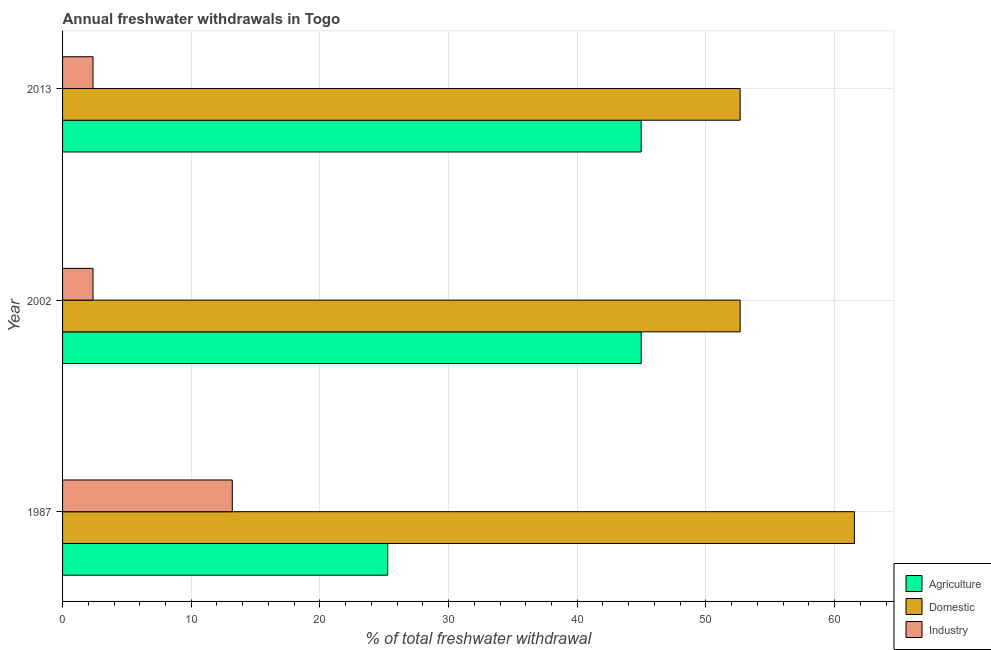How many different coloured bars are there?
Give a very brief answer. 3. How many groups of bars are there?
Your response must be concise. 3. Are the number of bars on each tick of the Y-axis equal?
Offer a very short reply. Yes. What is the label of the 2nd group of bars from the top?
Your answer should be compact. 2002. What is the percentage of freshwater withdrawal for domestic purposes in 2013?
Offer a very short reply. 52.66. Across all years, what is the maximum percentage of freshwater withdrawal for industry?
Give a very brief answer. 13.19. Across all years, what is the minimum percentage of freshwater withdrawal for agriculture?
Your response must be concise. 25.27. In which year was the percentage of freshwater withdrawal for domestic purposes maximum?
Offer a terse response. 1987. In which year was the percentage of freshwater withdrawal for industry minimum?
Make the answer very short. 2002. What is the total percentage of freshwater withdrawal for industry in the graph?
Offer a very short reply. 17.92. What is the difference between the percentage of freshwater withdrawal for agriculture in 1987 and that in 2013?
Offer a very short reply. -19.7. What is the difference between the percentage of freshwater withdrawal for domestic purposes in 1987 and the percentage of freshwater withdrawal for agriculture in 2013?
Your answer should be compact. 16.57. What is the average percentage of freshwater withdrawal for agriculture per year?
Offer a very short reply. 38.4. In the year 1987, what is the difference between the percentage of freshwater withdrawal for domestic purposes and percentage of freshwater withdrawal for industry?
Ensure brevity in your answer.  48.35. In how many years, is the percentage of freshwater withdrawal for agriculture greater than 62 %?
Offer a very short reply. 0. What is the ratio of the percentage of freshwater withdrawal for agriculture in 1987 to that in 2013?
Ensure brevity in your answer.  0.56. Is the difference between the percentage of freshwater withdrawal for domestic purposes in 1987 and 2013 greater than the difference between the percentage of freshwater withdrawal for agriculture in 1987 and 2013?
Provide a succinct answer. Yes. What is the difference between the highest and the second highest percentage of freshwater withdrawal for industry?
Provide a succinct answer. 10.82. What is the difference between the highest and the lowest percentage of freshwater withdrawal for domestic purposes?
Your response must be concise. 8.88. In how many years, is the percentage of freshwater withdrawal for industry greater than the average percentage of freshwater withdrawal for industry taken over all years?
Provide a short and direct response. 1. Is the sum of the percentage of freshwater withdrawal for industry in 2002 and 2013 greater than the maximum percentage of freshwater withdrawal for domestic purposes across all years?
Your answer should be very brief. No. What does the 2nd bar from the top in 2002 represents?
Your answer should be very brief. Domestic. What does the 1st bar from the bottom in 2002 represents?
Keep it short and to the point. Agriculture. Is it the case that in every year, the sum of the percentage of freshwater withdrawal for agriculture and percentage of freshwater withdrawal for domestic purposes is greater than the percentage of freshwater withdrawal for industry?
Offer a terse response. Yes. Are all the bars in the graph horizontal?
Give a very brief answer. Yes. How many years are there in the graph?
Offer a terse response. 3. What is the difference between two consecutive major ticks on the X-axis?
Offer a very short reply. 10. Where does the legend appear in the graph?
Offer a very short reply. Bottom right. How many legend labels are there?
Give a very brief answer. 3. What is the title of the graph?
Offer a very short reply. Annual freshwater withdrawals in Togo. What is the label or title of the X-axis?
Keep it short and to the point. % of total freshwater withdrawal. What is the % of total freshwater withdrawal in Agriculture in 1987?
Keep it short and to the point. 25.27. What is the % of total freshwater withdrawal in Domestic in 1987?
Give a very brief answer. 61.54. What is the % of total freshwater withdrawal in Industry in 1987?
Your response must be concise. 13.19. What is the % of total freshwater withdrawal of Agriculture in 2002?
Give a very brief answer. 44.97. What is the % of total freshwater withdrawal of Domestic in 2002?
Make the answer very short. 52.66. What is the % of total freshwater withdrawal of Industry in 2002?
Ensure brevity in your answer.  2.37. What is the % of total freshwater withdrawal of Agriculture in 2013?
Make the answer very short. 44.97. What is the % of total freshwater withdrawal in Domestic in 2013?
Make the answer very short. 52.66. What is the % of total freshwater withdrawal in Industry in 2013?
Make the answer very short. 2.37. Across all years, what is the maximum % of total freshwater withdrawal of Agriculture?
Provide a succinct answer. 44.97. Across all years, what is the maximum % of total freshwater withdrawal in Domestic?
Provide a succinct answer. 61.54. Across all years, what is the maximum % of total freshwater withdrawal of Industry?
Your response must be concise. 13.19. Across all years, what is the minimum % of total freshwater withdrawal of Agriculture?
Your answer should be compact. 25.27. Across all years, what is the minimum % of total freshwater withdrawal of Domestic?
Provide a succinct answer. 52.66. Across all years, what is the minimum % of total freshwater withdrawal in Industry?
Ensure brevity in your answer.  2.37. What is the total % of total freshwater withdrawal in Agriculture in the graph?
Keep it short and to the point. 115.21. What is the total % of total freshwater withdrawal in Domestic in the graph?
Offer a terse response. 166.86. What is the total % of total freshwater withdrawal in Industry in the graph?
Make the answer very short. 17.92. What is the difference between the % of total freshwater withdrawal in Agriculture in 1987 and that in 2002?
Ensure brevity in your answer.  -19.7. What is the difference between the % of total freshwater withdrawal of Domestic in 1987 and that in 2002?
Offer a very short reply. 8.88. What is the difference between the % of total freshwater withdrawal in Industry in 1987 and that in 2002?
Give a very brief answer. 10.82. What is the difference between the % of total freshwater withdrawal of Agriculture in 1987 and that in 2013?
Keep it short and to the point. -19.7. What is the difference between the % of total freshwater withdrawal in Domestic in 1987 and that in 2013?
Offer a terse response. 8.88. What is the difference between the % of total freshwater withdrawal in Industry in 1987 and that in 2013?
Keep it short and to the point. 10.82. What is the difference between the % of total freshwater withdrawal in Domestic in 2002 and that in 2013?
Your answer should be very brief. 0. What is the difference between the % of total freshwater withdrawal in Agriculture in 1987 and the % of total freshwater withdrawal in Domestic in 2002?
Provide a short and direct response. -27.39. What is the difference between the % of total freshwater withdrawal of Agriculture in 1987 and the % of total freshwater withdrawal of Industry in 2002?
Your answer should be compact. 22.9. What is the difference between the % of total freshwater withdrawal of Domestic in 1987 and the % of total freshwater withdrawal of Industry in 2002?
Provide a succinct answer. 59.17. What is the difference between the % of total freshwater withdrawal of Agriculture in 1987 and the % of total freshwater withdrawal of Domestic in 2013?
Provide a succinct answer. -27.39. What is the difference between the % of total freshwater withdrawal of Agriculture in 1987 and the % of total freshwater withdrawal of Industry in 2013?
Make the answer very short. 22.9. What is the difference between the % of total freshwater withdrawal in Domestic in 1987 and the % of total freshwater withdrawal in Industry in 2013?
Your answer should be very brief. 59.17. What is the difference between the % of total freshwater withdrawal in Agriculture in 2002 and the % of total freshwater withdrawal in Domestic in 2013?
Give a very brief answer. -7.69. What is the difference between the % of total freshwater withdrawal of Agriculture in 2002 and the % of total freshwater withdrawal of Industry in 2013?
Your response must be concise. 42.6. What is the difference between the % of total freshwater withdrawal in Domestic in 2002 and the % of total freshwater withdrawal in Industry in 2013?
Keep it short and to the point. 50.29. What is the average % of total freshwater withdrawal of Agriculture per year?
Your answer should be compact. 38.4. What is the average % of total freshwater withdrawal in Domestic per year?
Make the answer very short. 55.62. What is the average % of total freshwater withdrawal in Industry per year?
Your answer should be compact. 5.97. In the year 1987, what is the difference between the % of total freshwater withdrawal of Agriculture and % of total freshwater withdrawal of Domestic?
Offer a terse response. -36.27. In the year 1987, what is the difference between the % of total freshwater withdrawal of Agriculture and % of total freshwater withdrawal of Industry?
Provide a succinct answer. 12.08. In the year 1987, what is the difference between the % of total freshwater withdrawal in Domestic and % of total freshwater withdrawal in Industry?
Ensure brevity in your answer.  48.35. In the year 2002, what is the difference between the % of total freshwater withdrawal of Agriculture and % of total freshwater withdrawal of Domestic?
Your response must be concise. -7.69. In the year 2002, what is the difference between the % of total freshwater withdrawal in Agriculture and % of total freshwater withdrawal in Industry?
Your answer should be very brief. 42.6. In the year 2002, what is the difference between the % of total freshwater withdrawal in Domestic and % of total freshwater withdrawal in Industry?
Keep it short and to the point. 50.29. In the year 2013, what is the difference between the % of total freshwater withdrawal in Agriculture and % of total freshwater withdrawal in Domestic?
Make the answer very short. -7.69. In the year 2013, what is the difference between the % of total freshwater withdrawal of Agriculture and % of total freshwater withdrawal of Industry?
Your answer should be compact. 42.6. In the year 2013, what is the difference between the % of total freshwater withdrawal in Domestic and % of total freshwater withdrawal in Industry?
Your answer should be very brief. 50.29. What is the ratio of the % of total freshwater withdrawal of Agriculture in 1987 to that in 2002?
Offer a very short reply. 0.56. What is the ratio of the % of total freshwater withdrawal of Domestic in 1987 to that in 2002?
Make the answer very short. 1.17. What is the ratio of the % of total freshwater withdrawal of Industry in 1987 to that in 2002?
Your response must be concise. 5.57. What is the ratio of the % of total freshwater withdrawal of Agriculture in 1987 to that in 2013?
Ensure brevity in your answer.  0.56. What is the ratio of the % of total freshwater withdrawal in Domestic in 1987 to that in 2013?
Offer a very short reply. 1.17. What is the ratio of the % of total freshwater withdrawal in Industry in 1987 to that in 2013?
Offer a terse response. 5.57. What is the ratio of the % of total freshwater withdrawal in Agriculture in 2002 to that in 2013?
Provide a short and direct response. 1. What is the ratio of the % of total freshwater withdrawal in Domestic in 2002 to that in 2013?
Make the answer very short. 1. What is the difference between the highest and the second highest % of total freshwater withdrawal of Agriculture?
Provide a succinct answer. 0. What is the difference between the highest and the second highest % of total freshwater withdrawal in Domestic?
Keep it short and to the point. 8.88. What is the difference between the highest and the second highest % of total freshwater withdrawal in Industry?
Keep it short and to the point. 10.82. What is the difference between the highest and the lowest % of total freshwater withdrawal in Agriculture?
Your answer should be compact. 19.7. What is the difference between the highest and the lowest % of total freshwater withdrawal in Domestic?
Offer a terse response. 8.88. What is the difference between the highest and the lowest % of total freshwater withdrawal in Industry?
Give a very brief answer. 10.82. 